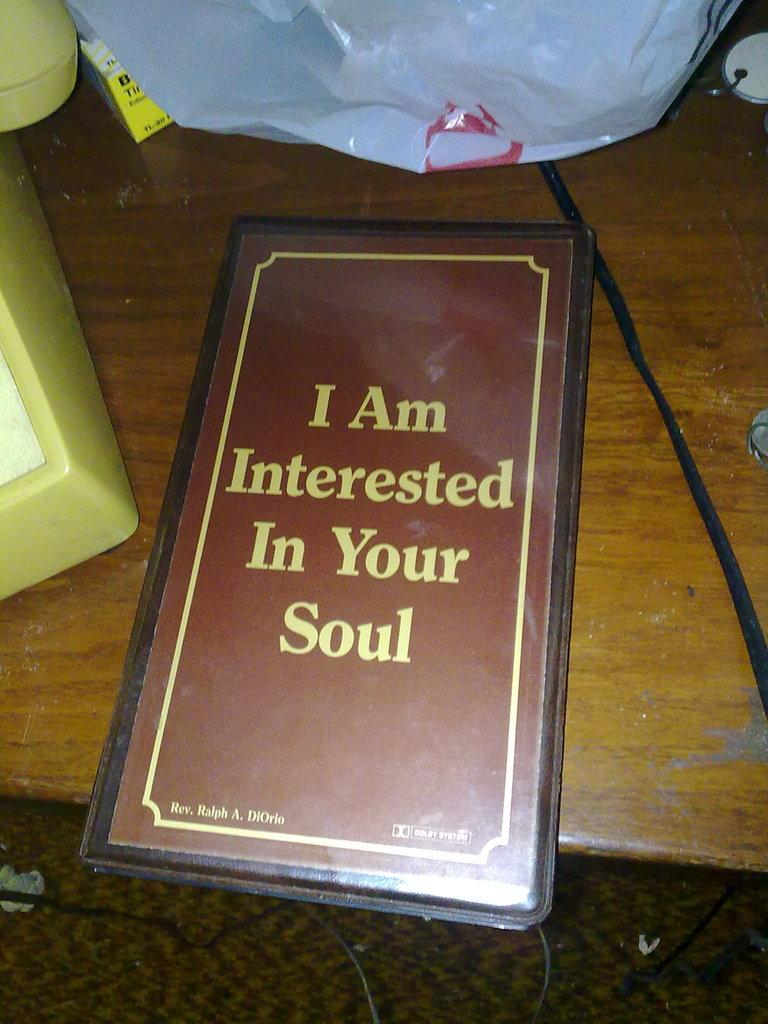<image>
Create a compact narrative representing the image presented. A menu with the wording "I am interested in your soul" is on a table 